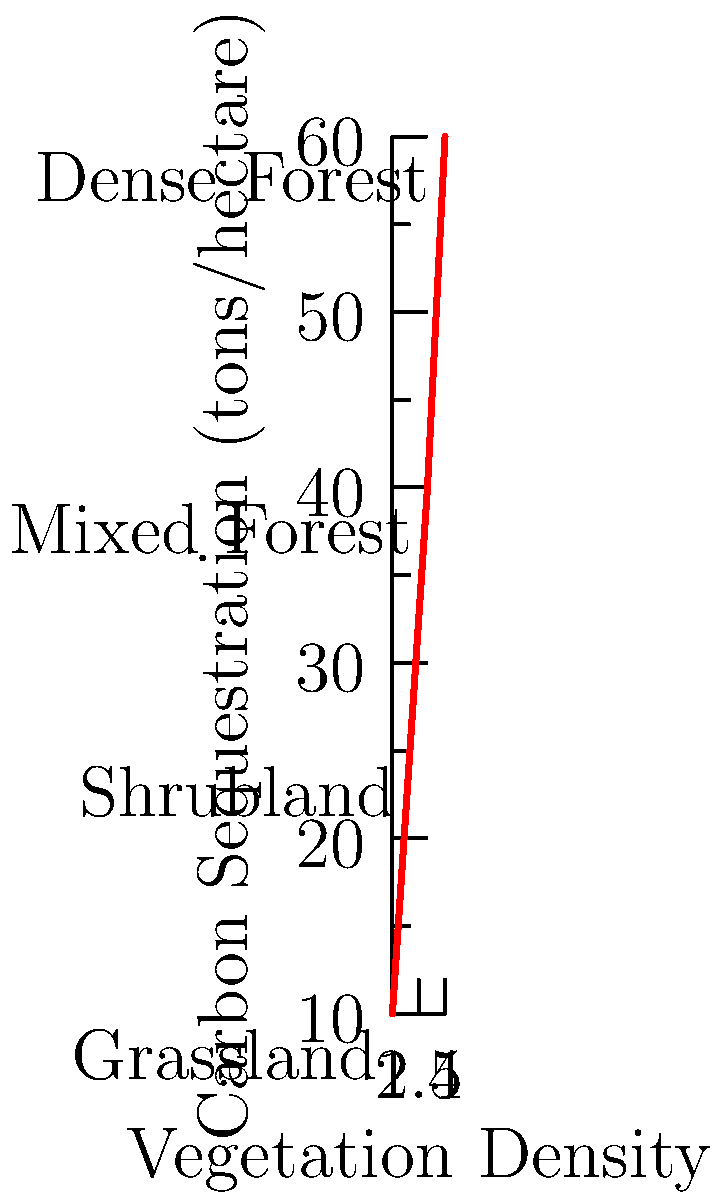Based on the graph showing the relationship between vegetation density and carbon sequestration potential, which type of vegetation cover would be most effective for maximizing carbon sequestration in a reforestation project aimed at mitigating habitat loss? To answer this question, we need to analyze the graph and understand the relationship between vegetation density and carbon sequestration potential:

1. The x-axis represents vegetation density, increasing from left to right.
2. The y-axis represents carbon sequestration in tons per hectare.
3. The graph shows four vegetation types: Grassland, Shrubland, Mixed Forest, and Dense Forest.
4. We can see a clear positive correlation between vegetation density and carbon sequestration potential.

Analyzing each vegetation type:
1. Grassland (x=1): Approximately 10 tons/hectare
2. Shrubland (x=2): Approximately 25 tons/hectare
3. Mixed Forest (x=3): Approximately 40 tons/hectare
4. Dense Forest (x=4): Approximately 60 tons/hectare

The Dense Forest has the highest vegetation density and corresponds to the highest carbon sequestration potential at about 60 tons per hectare. This is significantly higher than the other vegetation types.

Therefore, to maximize carbon sequestration in a reforestation project aimed at mitigating habitat loss, the most effective vegetation cover would be Dense Forest.
Answer: Dense Forest 